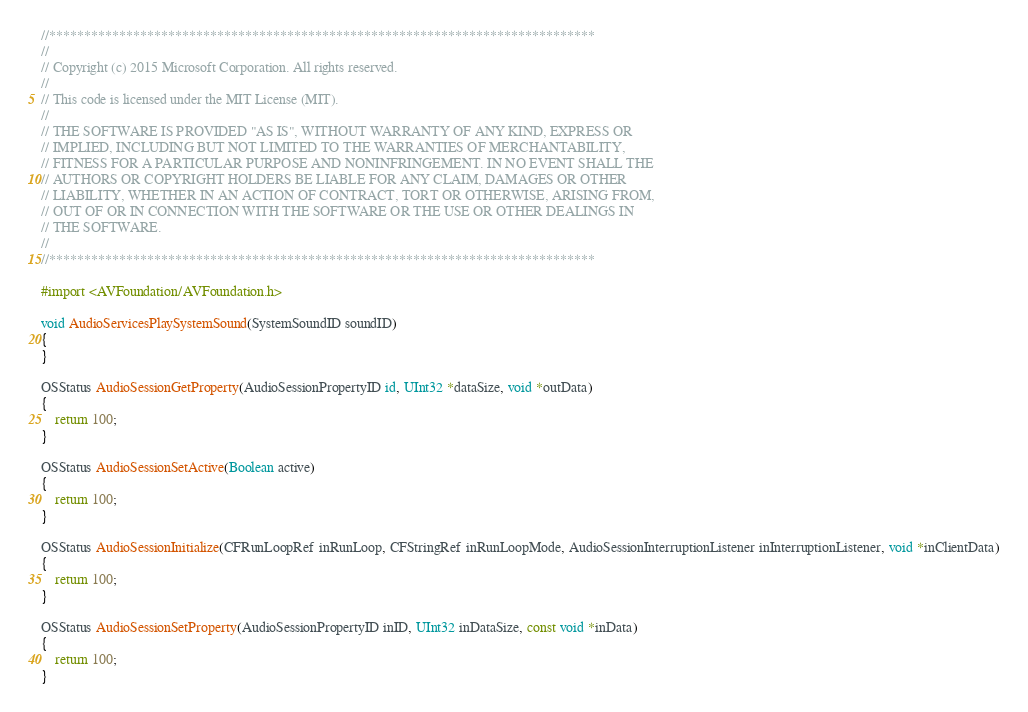<code> <loc_0><loc_0><loc_500><loc_500><_ObjectiveC_>//******************************************************************************
//
// Copyright (c) 2015 Microsoft Corporation. All rights reserved.
//
// This code is licensed under the MIT License (MIT).
//
// THE SOFTWARE IS PROVIDED "AS IS", WITHOUT WARRANTY OF ANY KIND, EXPRESS OR
// IMPLIED, INCLUDING BUT NOT LIMITED TO THE WARRANTIES OF MERCHANTABILITY,
// FITNESS FOR A PARTICULAR PURPOSE AND NONINFRINGEMENT. IN NO EVENT SHALL THE
// AUTHORS OR COPYRIGHT HOLDERS BE LIABLE FOR ANY CLAIM, DAMAGES OR OTHER
// LIABILITY, WHETHER IN AN ACTION OF CONTRACT, TORT OR OTHERWISE, ARISING FROM,
// OUT OF OR IN CONNECTION WITH THE SOFTWARE OR THE USE OR OTHER DEALINGS IN
// THE SOFTWARE.
//
//******************************************************************************

#import <AVFoundation/AVFoundation.h>

void AudioServicesPlaySystemSound(SystemSoundID soundID)
{
}

OSStatus AudioSessionGetProperty(AudioSessionPropertyID id, UInt32 *dataSize, void *outData)
{
    return 100;
}

OSStatus AudioSessionSetActive(Boolean active)
{
    return 100;
}

OSStatus AudioSessionInitialize(CFRunLoopRef inRunLoop, CFStringRef inRunLoopMode, AudioSessionInterruptionListener inInterruptionListener, void *inClientData)
{
    return 100;
}

OSStatus AudioSessionSetProperty(AudioSessionPropertyID inID, UInt32 inDataSize, const void *inData)
{
    return 100;
}

</code> 